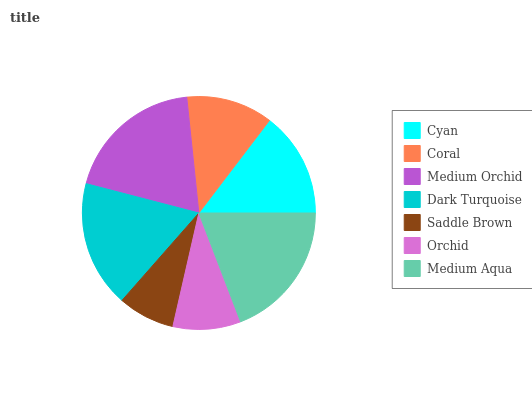Is Saddle Brown the minimum?
Answer yes or no. Yes. Is Medium Orchid the maximum?
Answer yes or no. Yes. Is Coral the minimum?
Answer yes or no. No. Is Coral the maximum?
Answer yes or no. No. Is Cyan greater than Coral?
Answer yes or no. Yes. Is Coral less than Cyan?
Answer yes or no. Yes. Is Coral greater than Cyan?
Answer yes or no. No. Is Cyan less than Coral?
Answer yes or no. No. Is Cyan the high median?
Answer yes or no. Yes. Is Cyan the low median?
Answer yes or no. Yes. Is Saddle Brown the high median?
Answer yes or no. No. Is Saddle Brown the low median?
Answer yes or no. No. 